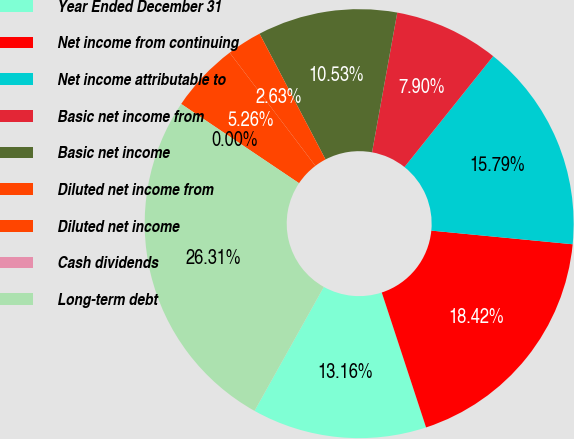<chart> <loc_0><loc_0><loc_500><loc_500><pie_chart><fcel>Year Ended December 31<fcel>Net income from continuing<fcel>Net income attributable to<fcel>Basic net income from<fcel>Basic net income<fcel>Diluted net income from<fcel>Diluted net income<fcel>Cash dividends<fcel>Long-term debt<nl><fcel>13.16%<fcel>18.42%<fcel>15.79%<fcel>7.9%<fcel>10.53%<fcel>2.63%<fcel>5.26%<fcel>0.0%<fcel>26.31%<nl></chart> 